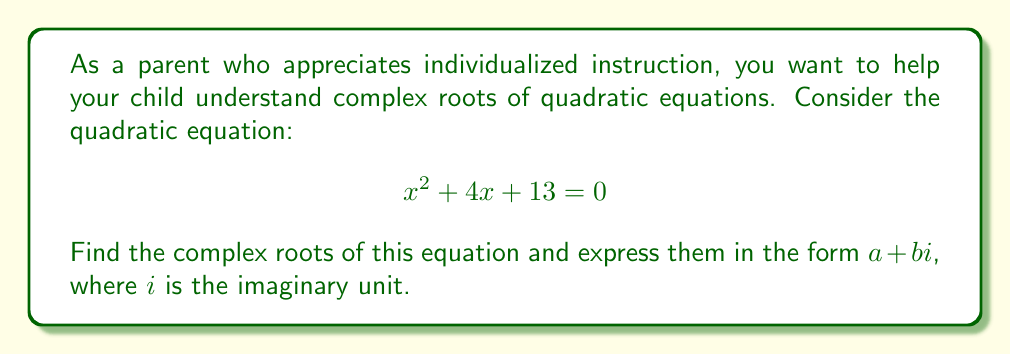Could you help me with this problem? Let's solve this step-by-step:

1) First, we'll use the quadratic formula. For a quadratic equation in the form $ax^2 + bx + c = 0$, the roots are given by:

   $$ x = \frac{-b \pm \sqrt{b^2 - 4ac}}{2a} $$

2) In our equation, $a=1$, $b=4$, and $c=13$. Let's substitute these values:

   $$ x = \frac{-4 \pm \sqrt{4^2 - 4(1)(13)}}{2(1)} $$

3) Simplify under the square root:

   $$ x = \frac{-4 \pm \sqrt{16 - 52}}{2} = \frac{-4 \pm \sqrt{-36}}{2} $$

4) Simplify $\sqrt{-36}$:

   $$ \sqrt{-36} = \sqrt{36} \cdot \sqrt{-1} = 6i $$

5) Therefore, our equation becomes:

   $$ x = \frac{-4 \pm 6i}{2} $$

6) Simplify:

   $$ x = -2 \pm 3i $$

7) This gives us two complex roots:
   
   $x_1 = -2 + 3i$ and $x_2 = -2 - 3i$

These roots are complex conjugates, which is always the case for quadratic equations with real coefficients and complex roots.
Answer: The complex roots are $x_1 = -2 + 3i$ and $x_2 = -2 - 3i$. 